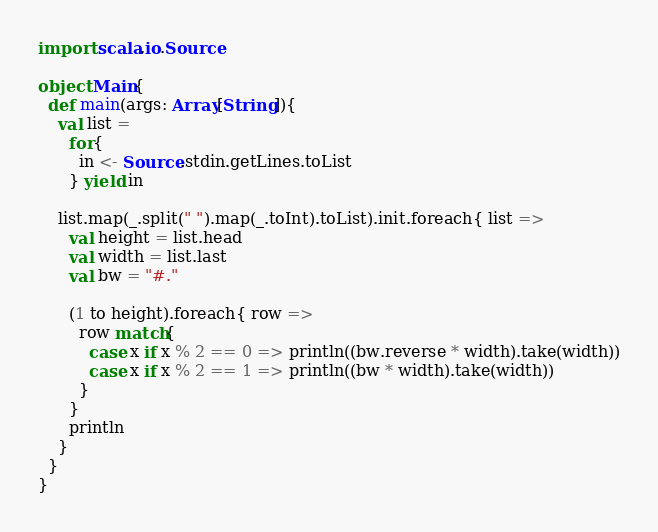<code> <loc_0><loc_0><loc_500><loc_500><_Scala_>import scala.io.Source

object Main{
  def main(args: Array[String]){
    val list =
      for{
        in <- Source.stdin.getLines.toList
      } yield in

    list.map(_.split(" ").map(_.toInt).toList).init.foreach{ list =>
      val height = list.head
      val width = list.last
      val bw = "#."

      (1 to height).foreach{ row =>
        row match{
          case x if x % 2 == 0 => println((bw.reverse * width).take(width))
          case x if x % 2 == 1 => println((bw * width).take(width))
        }
      }
      println
    }
  }
}</code> 